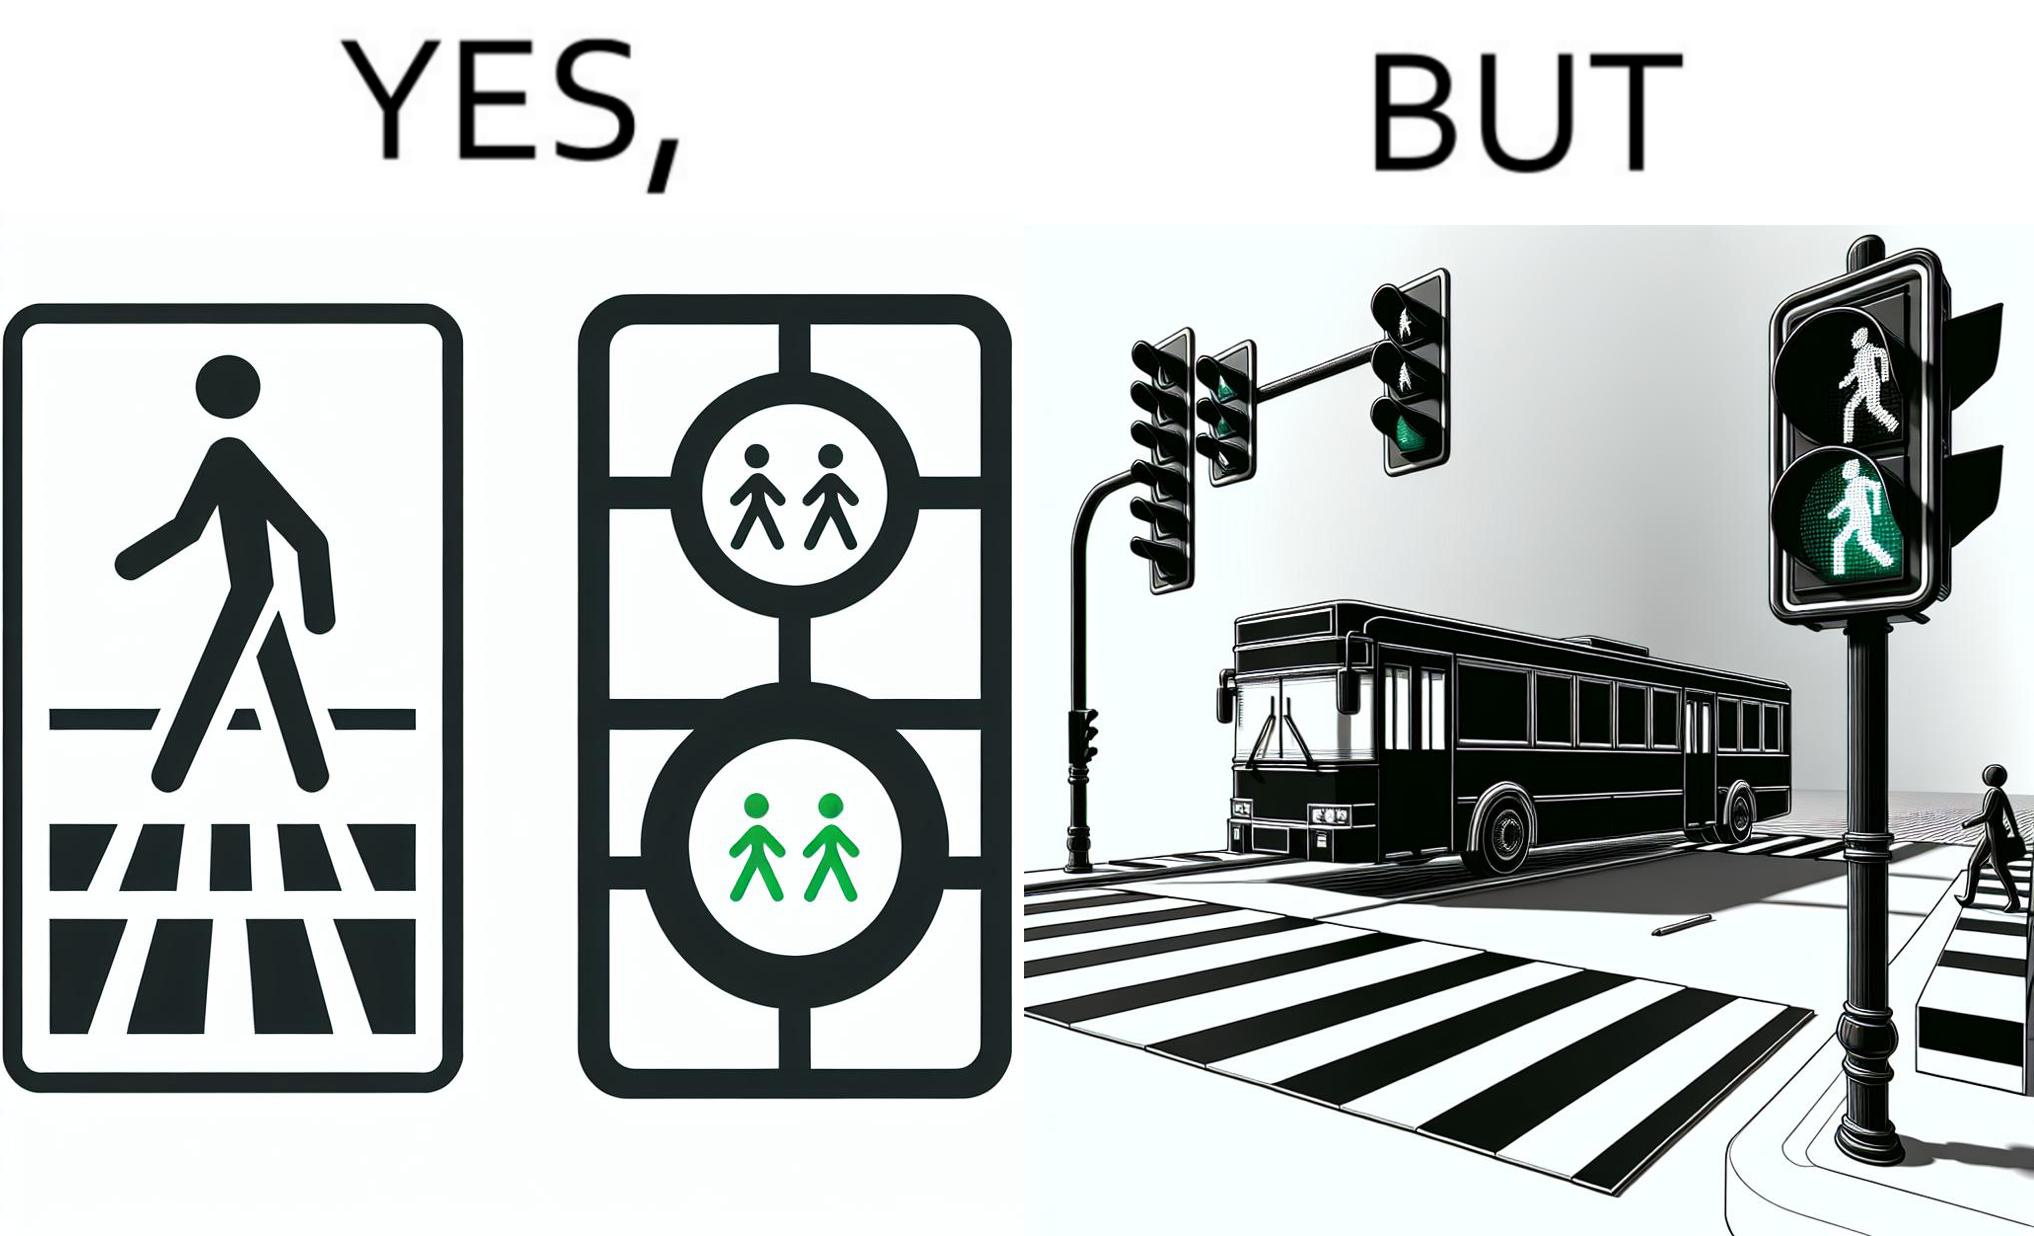What is shown in the left half versus the right half of this image? In the left part of the image: a traffic signal for the pedestrians and the signal is green, so pedestrians can cross the road In the right part of the image: a bus standing on the zebra crossing, while the traffic signal is green for the pedestrians symbolising  they can cross the road now 